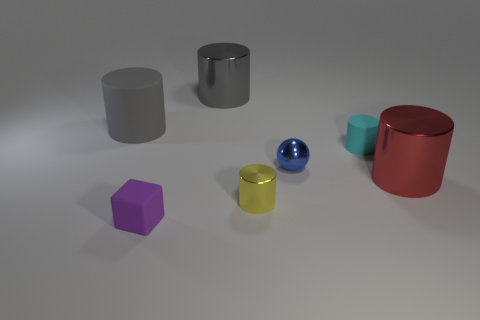Are there any other things that have the same shape as the purple rubber object?
Ensure brevity in your answer.  No. What material is the yellow cylinder?
Offer a terse response. Metal. The shiny cylinder behind the small rubber object that is to the right of the metal cylinder in front of the red metal object is what color?
Offer a terse response. Gray. How many purple objects are the same size as the yellow metal cylinder?
Provide a succinct answer. 1. There is a shiny cylinder behind the ball; what is its color?
Your response must be concise. Gray. What number of other objects are there of the same size as the cyan thing?
Give a very brief answer. 3. There is a metallic cylinder that is behind the yellow object and to the left of the big red metallic object; what is its size?
Provide a succinct answer. Large. Does the large matte cylinder have the same color as the big shiny thing that is to the left of the small cyan rubber cylinder?
Ensure brevity in your answer.  Yes. Are there any brown matte objects that have the same shape as the tiny cyan thing?
Give a very brief answer. No. What number of objects are small things or rubber things that are behind the tiny purple rubber cube?
Offer a very short reply. 5. 